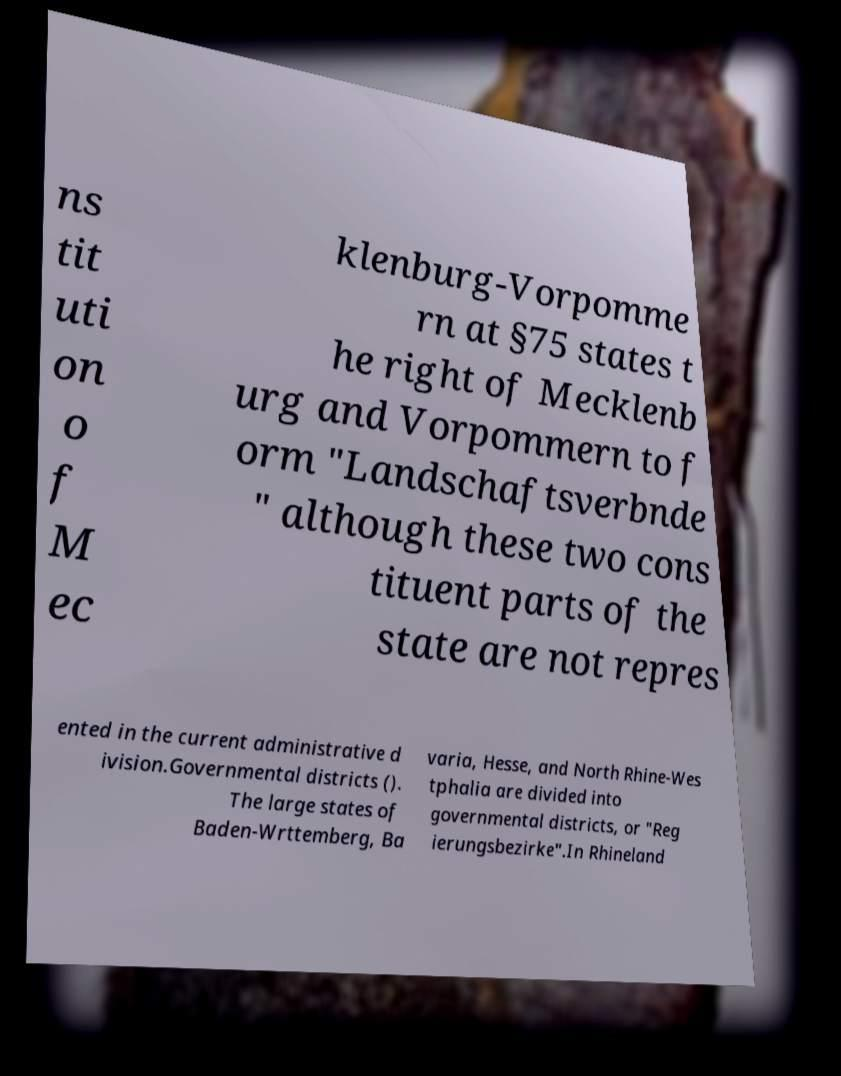I need the written content from this picture converted into text. Can you do that? ns tit uti on o f M ec klenburg-Vorpomme rn at §75 states t he right of Mecklenb urg and Vorpommern to f orm "Landschaftsverbnde " although these two cons tituent parts of the state are not repres ented in the current administrative d ivision.Governmental districts (). The large states of Baden-Wrttemberg, Ba varia, Hesse, and North Rhine-Wes tphalia are divided into governmental districts, or "Reg ierungsbezirke".In Rhineland 